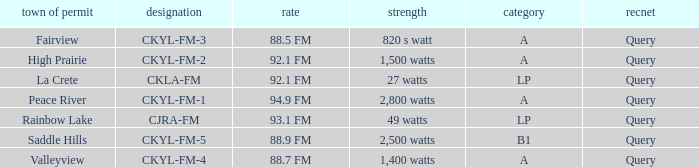What is the identifier with 94.9 fm frequency CKYL-FM-1. 